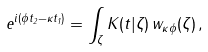Convert formula to latex. <formula><loc_0><loc_0><loc_500><loc_500>e ^ { i ( \phi t _ { 2 } - \kappa t _ { 1 } ) } = \int _ { \zeta } K ( t | \zeta ) \, w _ { \kappa \phi } ( \zeta ) \, ,</formula> 